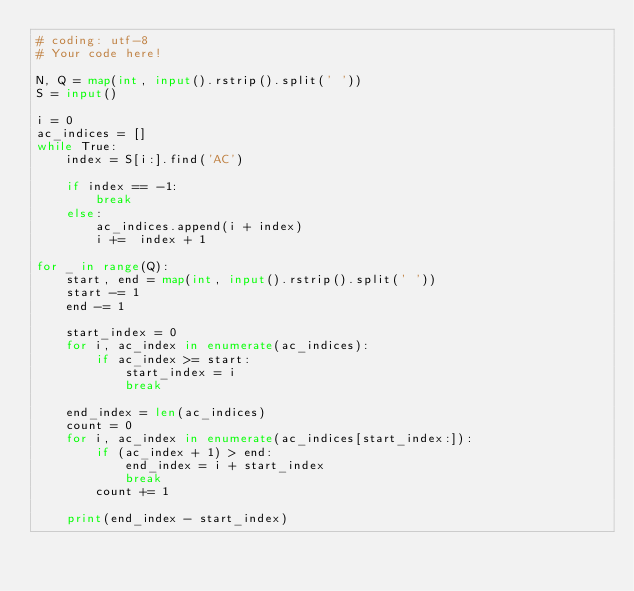Convert code to text. <code><loc_0><loc_0><loc_500><loc_500><_Python_># coding: utf-8
# Your code here!

N, Q = map(int, input().rstrip().split(' '))
S = input()

i = 0
ac_indices = []
while True:
    index = S[i:].find('AC')
  
    if index == -1:
        break
    else:
        ac_indices.append(i + index)
        i +=  index + 1

for _ in range(Q):
    start, end = map(int, input().rstrip().split(' '))
    start -= 1
    end -= 1
    
    start_index = 0
    for i, ac_index in enumerate(ac_indices):
        if ac_index >= start:
            start_index = i
            break
        
    end_index = len(ac_indices)
    count = 0
    for i, ac_index in enumerate(ac_indices[start_index:]):
        if (ac_index + 1) > end:
            end_index = i + start_index
            break
        count += 1
        
    print(end_index - start_index)

        </code> 